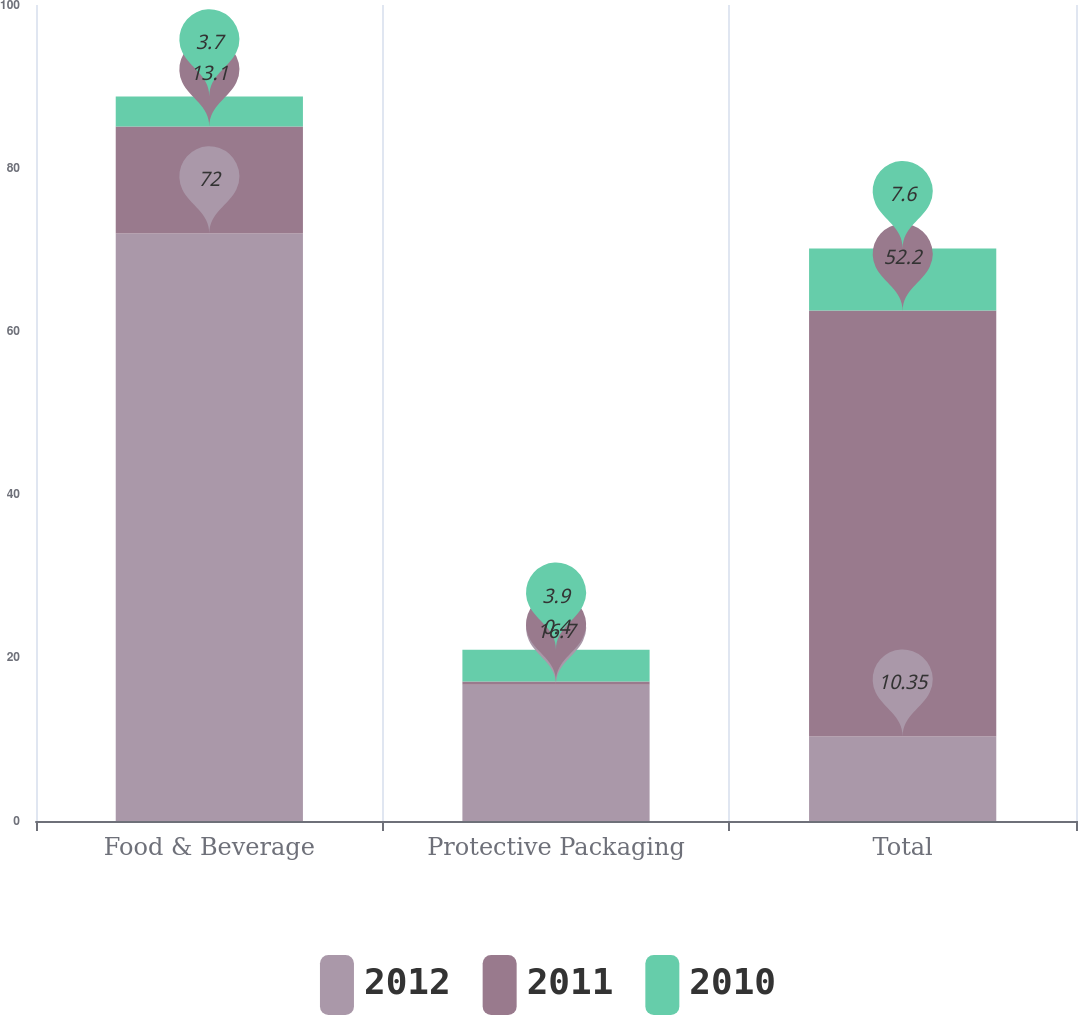Convert chart to OTSL. <chart><loc_0><loc_0><loc_500><loc_500><stacked_bar_chart><ecel><fcel>Food & Beverage<fcel>Protective Packaging<fcel>Total<nl><fcel>2012<fcel>72<fcel>16.7<fcel>10.35<nl><fcel>2011<fcel>13.1<fcel>0.4<fcel>52.2<nl><fcel>2010<fcel>3.7<fcel>3.9<fcel>7.6<nl></chart> 